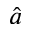Convert formula to latex. <formula><loc_0><loc_0><loc_500><loc_500>\hat { a }</formula> 